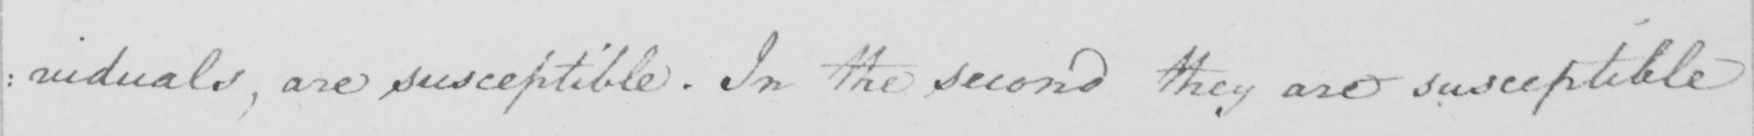What text is written in this handwritten line? : viduals  , are susceptible  . In the second they are susceptible 